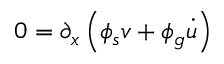Convert formula to latex. <formula><loc_0><loc_0><loc_500><loc_500>0 = \partial _ { x } \left ( \phi _ { s } v + \phi _ { g } \dot { u } \right )</formula> 